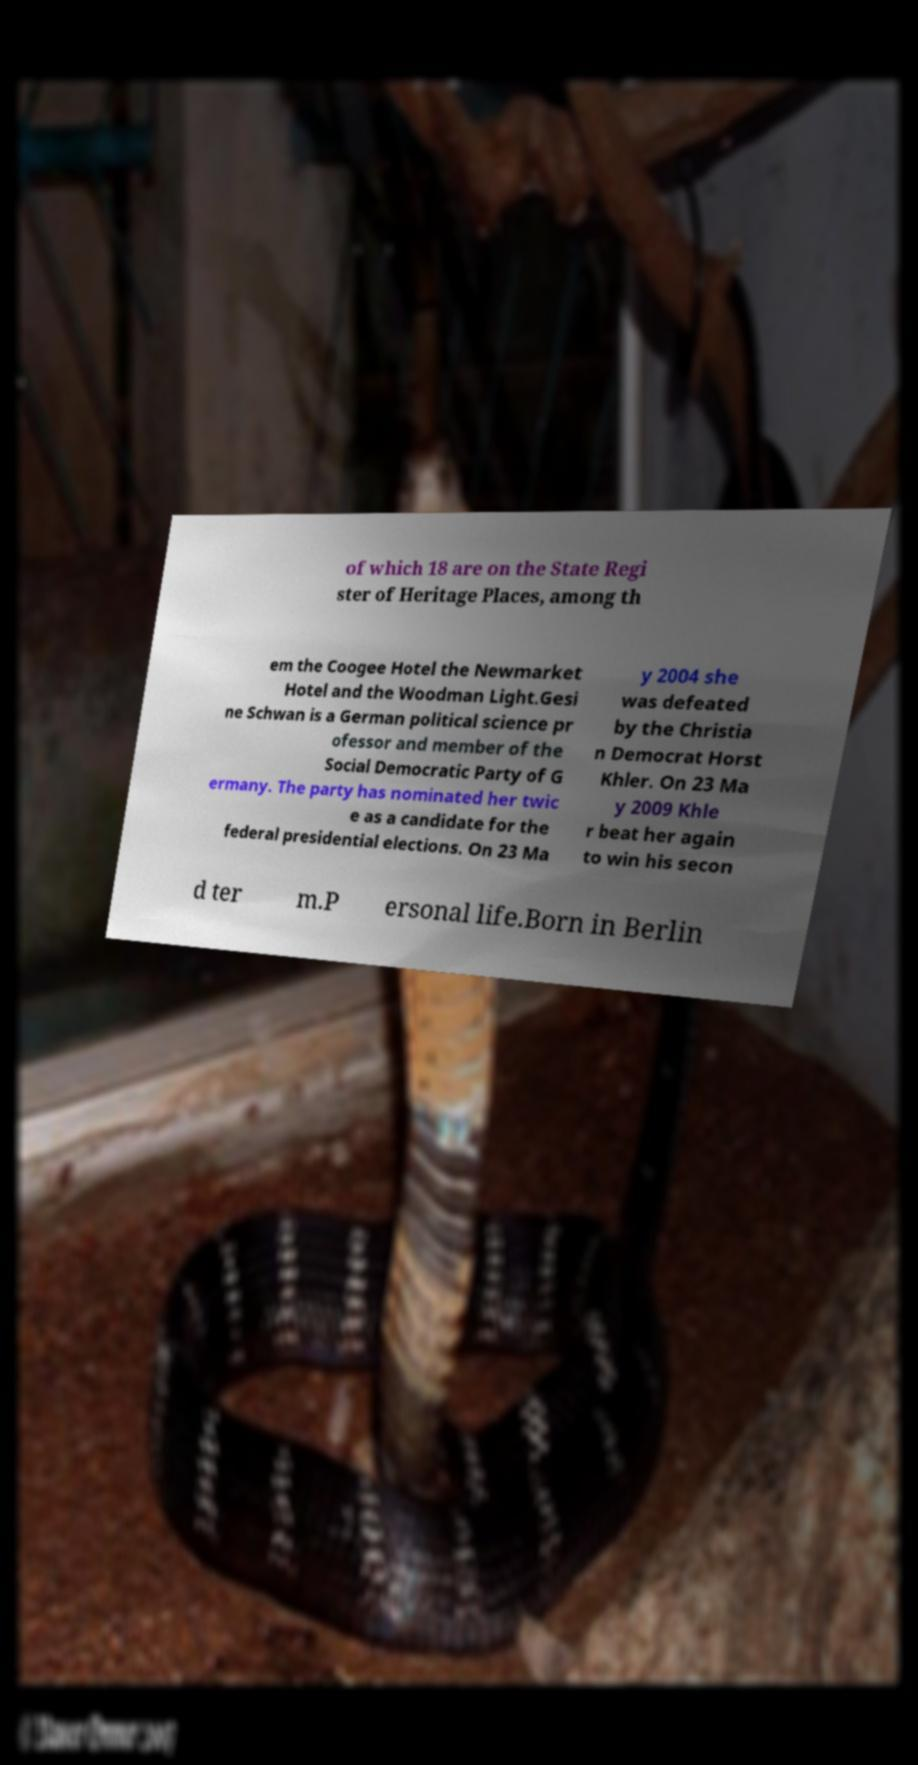What messages or text are displayed in this image? I need them in a readable, typed format. of which 18 are on the State Regi ster of Heritage Places, among th em the Coogee Hotel the Newmarket Hotel and the Woodman Light.Gesi ne Schwan is a German political science pr ofessor and member of the Social Democratic Party of G ermany. The party has nominated her twic e as a candidate for the federal presidential elections. On 23 Ma y 2004 she was defeated by the Christia n Democrat Horst Khler. On 23 Ma y 2009 Khle r beat her again to win his secon d ter m.P ersonal life.Born in Berlin 